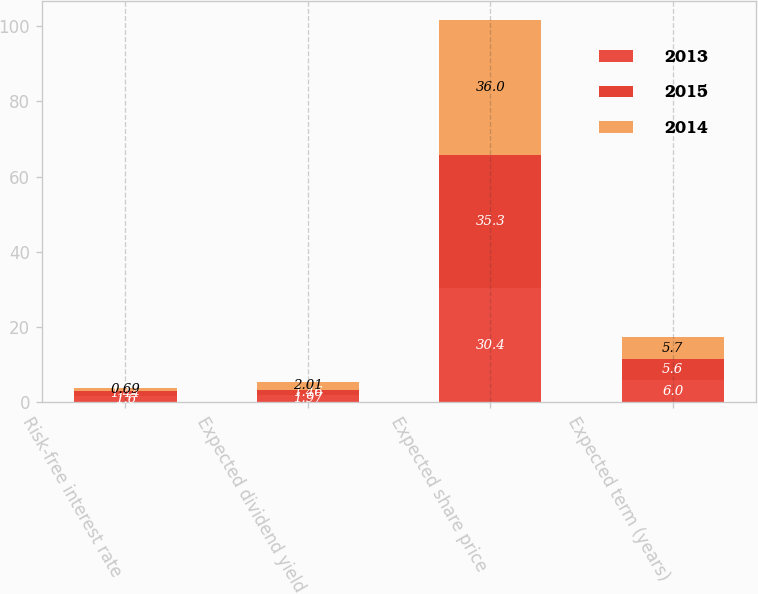Convert chart. <chart><loc_0><loc_0><loc_500><loc_500><stacked_bar_chart><ecel><fcel>Risk-free interest rate<fcel>Expected dividend yield<fcel>Expected share price<fcel>Expected term (years)<nl><fcel>2013<fcel>1.6<fcel>1.97<fcel>30.4<fcel>6<nl><fcel>2015<fcel>1.44<fcel>1.46<fcel>35.3<fcel>5.6<nl><fcel>2014<fcel>0.69<fcel>2.01<fcel>36<fcel>5.7<nl></chart> 